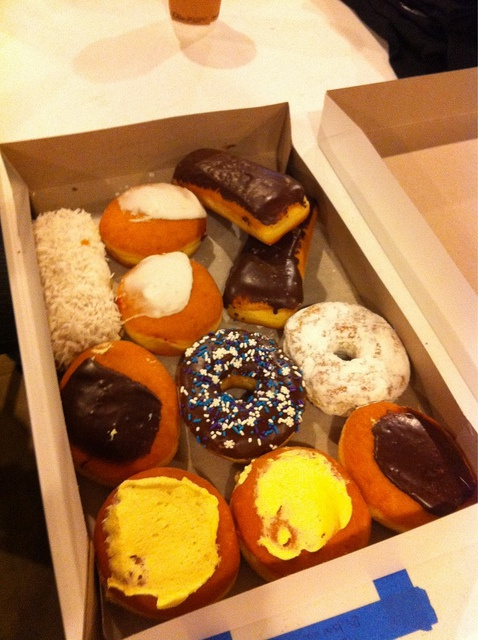Describe the objects in this image and their specific colors. I can see donut in khaki, gold, orange, maroon, and red tones, donut in khaki, black, maroon, and red tones, donut in khaki, yellow, red, maroon, and gold tones, donut in khaki, maroon, black, and tan tones, and donut in khaki, maroon, and red tones in this image. 